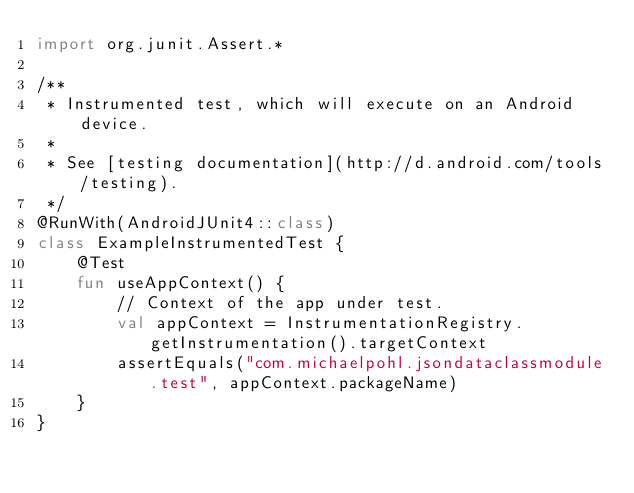Convert code to text. <code><loc_0><loc_0><loc_500><loc_500><_Kotlin_>import org.junit.Assert.*

/**
 * Instrumented test, which will execute on an Android device.
 *
 * See [testing documentation](http://d.android.com/tools/testing).
 */
@RunWith(AndroidJUnit4::class)
class ExampleInstrumentedTest {
    @Test
    fun useAppContext() {
        // Context of the app under test.
        val appContext = InstrumentationRegistry.getInstrumentation().targetContext
        assertEquals("com.michaelpohl.jsondataclassmodule.test", appContext.packageName)
    }
}
</code> 